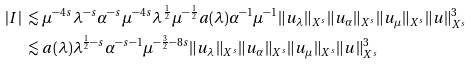Convert formula to latex. <formula><loc_0><loc_0><loc_500><loc_500>| I | & \ \lesssim \mu ^ { - 4 s } \lambda ^ { - s } \alpha ^ { - s } \mu ^ { - 4 s } \lambda ^ { \frac { 1 } { 2 } } \mu ^ { - \frac { 1 } { 2 } } a ( \lambda ) \alpha ^ { - 1 } \mu ^ { - 1 } \| u _ { \lambda } \| _ { X ^ { s } } \| u _ { \alpha } \| _ { X ^ { s } } \| u _ { \mu } \| _ { X ^ { s } } \| u \| _ { X ^ { s } } ^ { 3 } \\ & \ \lesssim a ( \lambda ) \lambda ^ { \frac { 1 } { 2 } - s } \alpha ^ { - s - 1 } \mu ^ { - \frac { 3 } { 2 } - 8 s } \| u _ { \lambda } \| _ { X ^ { s } } \| u _ { \alpha } \| _ { X ^ { s } } \| u _ { \mu } \| _ { X ^ { s } } \| u \| _ { X ^ { s } } ^ { 3 }</formula> 